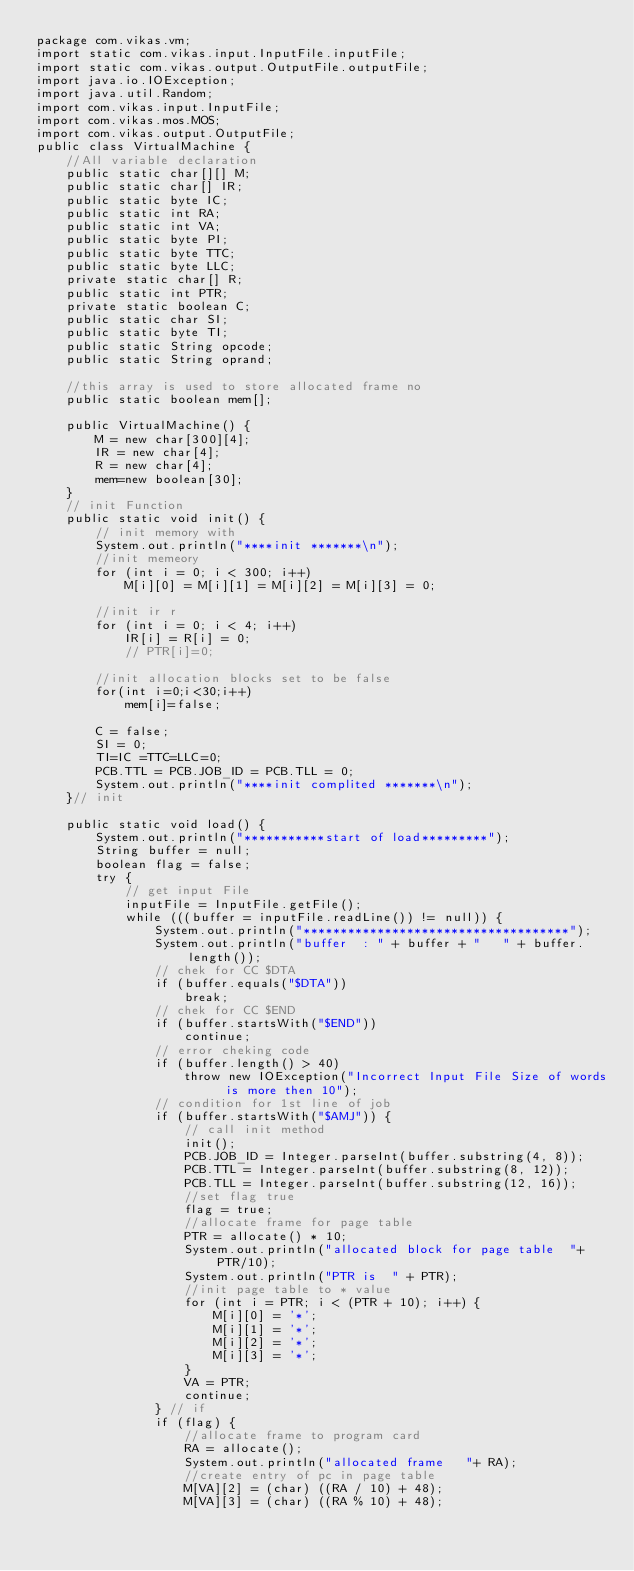Convert code to text. <code><loc_0><loc_0><loc_500><loc_500><_Java_>package com.vikas.vm;
import static com.vikas.input.InputFile.inputFile;
import static com.vikas.output.OutputFile.outputFile;
import java.io.IOException;
import java.util.Random;
import com.vikas.input.InputFile;
import com.vikas.mos.MOS;
import com.vikas.output.OutputFile;
public class VirtualMachine {
	//All variable declaration
	public static char[][] M;
	public static char[] IR;
	public static byte IC;
	public static int RA;
	public static int VA;
	public static byte PI;
	public static byte TTC;
	public static byte LLC;
	private static char[] R;
	public static int PTR;
	private static boolean C;
	public static char SI;
	public static byte TI;
	public static String opcode;
	public static String oprand;
	
	//this array is used to store allocated frame no
	public static boolean mem[];

	public VirtualMachine() {
		M = new char[300][4];
		IR = new char[4];
		R = new char[4];
		mem=new boolean[30];
	}
	// init Function
	public static void init() {
		// init memory with
		System.out.println("****init *******\n");
		//init memeory
		for (int i = 0; i < 300; i++)
			M[i][0] = M[i][1] = M[i][2] = M[i][3] = 0;
		
		//init ir r
		for (int i = 0; i < 4; i++) 
			IR[i] = R[i] = 0;
			// PTR[i]=0;
			
		//init allocation blocks set to be false
		for(int i=0;i<30;i++)
			mem[i]=false;
		
		C = false;
		SI = 0;
		TI=IC =TTC=LLC=0;
		PCB.TTL = PCB.JOB_ID = PCB.TLL = 0;
		System.out.println("****init complited *******\n");
	}// init
	
	public static void load() {
		System.out.println("***********start of load*********");
		String buffer = null;
		boolean flag = false;
		try {
			// get input File
			inputFile = InputFile.getFile();
			while (((buffer = inputFile.readLine()) != null)) {
				System.out.println("************************************");
				System.out.println("buffer  : " + buffer + "   " + buffer.length());
				// chek for CC $DTA
				if (buffer.equals("$DTA"))
					break;
				// chek for CC $END
				if (buffer.startsWith("$END"))
					continue;
				// error cheking code
				if (buffer.length() > 40)
					throw new IOException("Incorrect Input File Size of words is more then 10");
				// condition for 1st line of job
				if (buffer.startsWith("$AMJ")) {
					// call init method
					init();
					PCB.JOB_ID = Integer.parseInt(buffer.substring(4, 8));
					PCB.TTL = Integer.parseInt(buffer.substring(8, 12));
					PCB.TLL = Integer.parseInt(buffer.substring(12, 16));
					//set flag true
					flag = true;
					//allocate frame for page table
					PTR = allocate() * 10;
					System.out.println("allocated block for page table  "+ PTR/10);
					System.out.println("PTR is  " + PTR);
					//init page table to * value
					for (int i = PTR; i < (PTR + 10); i++) {
						M[i][0] = '*';
						M[i][1] = '*';
						M[i][2] = '*';
						M[i][3] = '*';
					}
					VA = PTR;
					continue;
				} // if
				if (flag) {
					//allocate frame to program card
					RA = allocate();
					System.out.println("allocated frame   "+ RA);
					//create entry of pc in page table
					M[VA][2] = (char) ((RA / 10) + 48);
					M[VA][3] = (char) ((RA % 10) + 48);</code> 